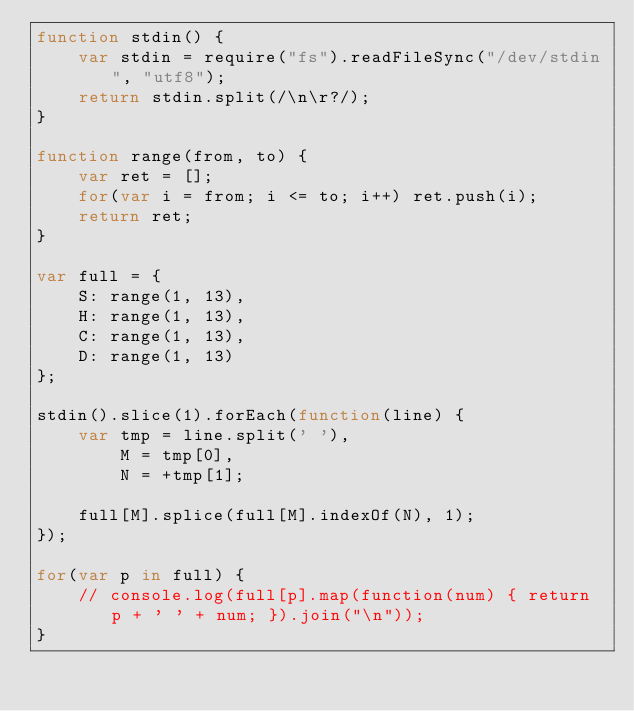<code> <loc_0><loc_0><loc_500><loc_500><_JavaScript_>function stdin() {
	var stdin = require("fs").readFileSync("/dev/stdin", "utf8");
	return stdin.split(/\n\r?/);
}

function range(from, to) {
	var ret = [];
	for(var i = from; i <= to; i++) ret.push(i);
	return ret;
}

var full = {
	S: range(1, 13),
	H: range(1, 13),
	C: range(1, 13),
	D: range(1, 13)
};

stdin().slice(1).forEach(function(line) {
	var tmp = line.split(' '),
		M = tmp[0],
		N = +tmp[1];

	full[M].splice(full[M].indexOf(N), 1);
});

for(var p in full) {
	// console.log(full[p].map(function(num) { return p + ' ' + num; }).join("\n"));
}</code> 